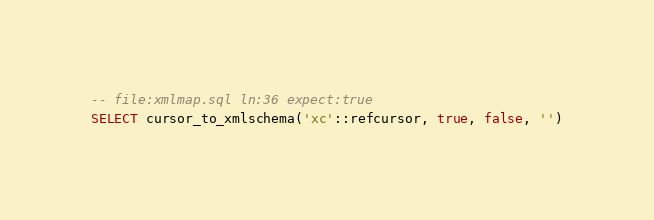<code> <loc_0><loc_0><loc_500><loc_500><_SQL_>-- file:xmlmap.sql ln:36 expect:true
SELECT cursor_to_xmlschema('xc'::refcursor, true, false, '')
</code> 